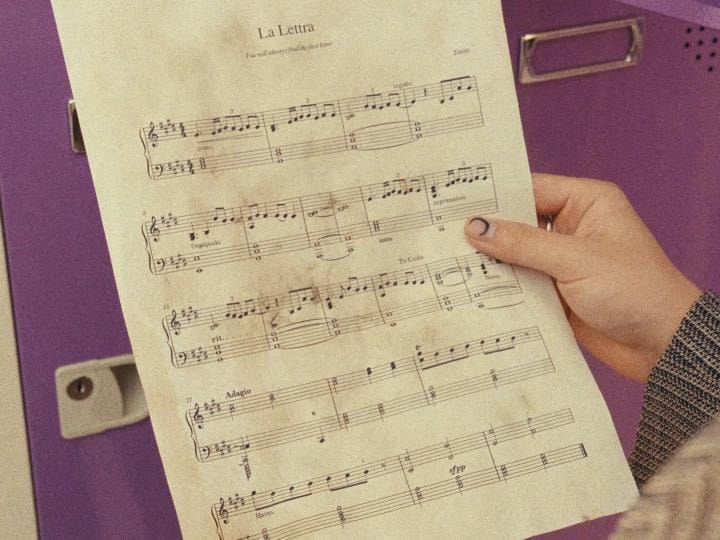List everything weird or unusual in the image. The image shows someone holding a sheet of music, but there are a few unusual aspects about it:

1. The title of the piece is "La Lettra", which does not appear to be a common or well-known musical composition.

2. The musical notation and layout on the page looks hand-written rather than professionally typeset and printed like most sheet music.

3. There are numbers written above certain measures, like "2." and "1.", which is an atypical marking to see on sheet music. The purpose of those numbers is unclear.

4. The paper itself looks somewhat aged and worn, giving it an unpolished appearance compared to typical printed sheet music.

So in summary, while it depicts sheet music, the piece itself, the handwritten style, added numerical markings, and aged paper quality diverge from what standard professionally published sheet music usually looks like. The photograph captures these quirky and DIY characteristics of this particular musical score. 